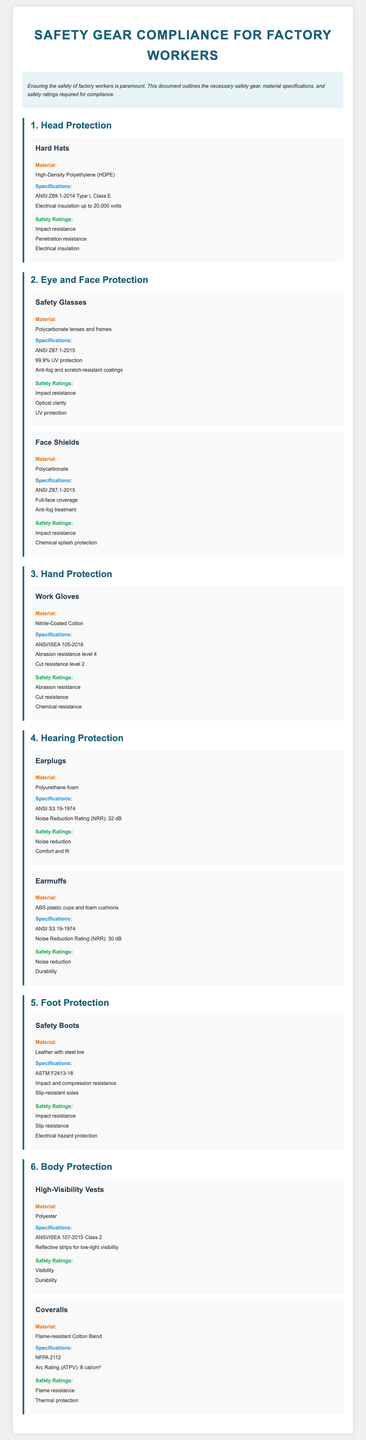What is the material of the hard hats? The hard hats are made from High-Density Polyethylene (HDPE), as stated in the document.
Answer: High-Density Polyethylene (HDPE) What is the Noise Reduction Rating of the earplugs? The Noise Reduction Rating (NRR) for the earplugs is listed in the specifications section.
Answer: 32 dB Which document provides the safety standard for safety glasses? The specifications for safety glasses cite ANSI Z87.1-2015 as the relevant safety standard.
Answer: ANSI Z87.1-2015 What type of gloves have a cut resistance level of 2? The work gloves are specifically mentioned to have a cut resistance level of 2 in the document.
Answer: Work Gloves What safety rating is associated with the coveralls? The coveralls are rated for flame resistance and thermal protection according to the safety ratings listed.
Answer: Flame resistance, Thermal protection What material is used for safety boots? The document specifies that safety boots are made from leather with a steel toe.
Answer: Leather with steel toe How many safety ratings are provided for earplugs? The document lists two specific safety ratings for earplugs.
Answer: Two What specifications apply to high-visibility vests? The high-visibility vests must meet ANSI/ISEA 107-2015 Class 2, according to the specifications section.
Answer: ANSI/ISEA 107-2015 Class 2 